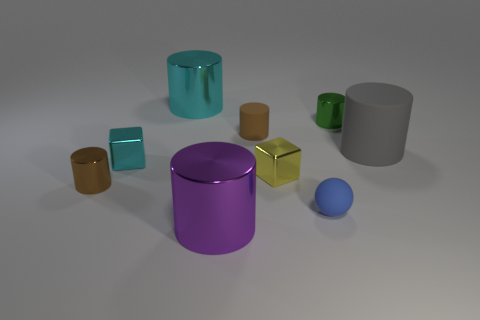Subtract all cyan cylinders. How many cylinders are left? 5 Subtract all green cylinders. How many cylinders are left? 5 Subtract all purple cylinders. Subtract all cyan spheres. How many cylinders are left? 5 Subtract all cylinders. How many objects are left? 3 Subtract 0 red cubes. How many objects are left? 9 Subtract all shiny things. Subtract all tiny green cylinders. How many objects are left? 2 Add 5 big shiny cylinders. How many big shiny cylinders are left? 7 Add 4 small metal cylinders. How many small metal cylinders exist? 6 